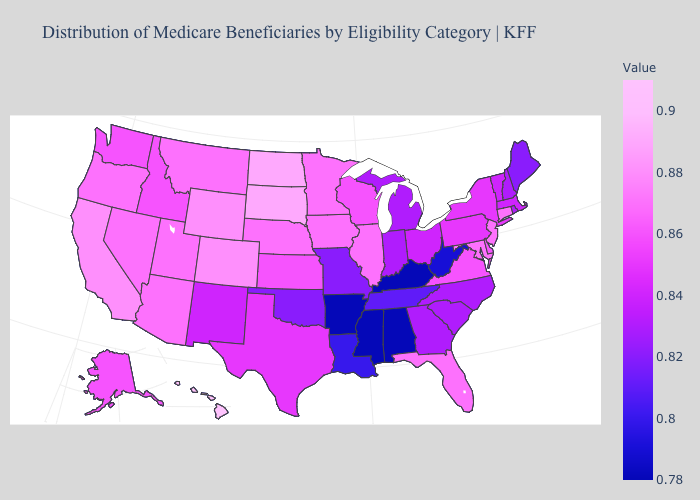Among the states that border Iowa , which have the lowest value?
Keep it brief. Missouri. Does Hawaii have the highest value in the West?
Concise answer only. Yes. Among the states that border New Hampshire , which have the lowest value?
Keep it brief. Maine. Does Delaware have a lower value than Indiana?
Short answer required. No. Among the states that border Oklahoma , which have the highest value?
Short answer required. Colorado. 